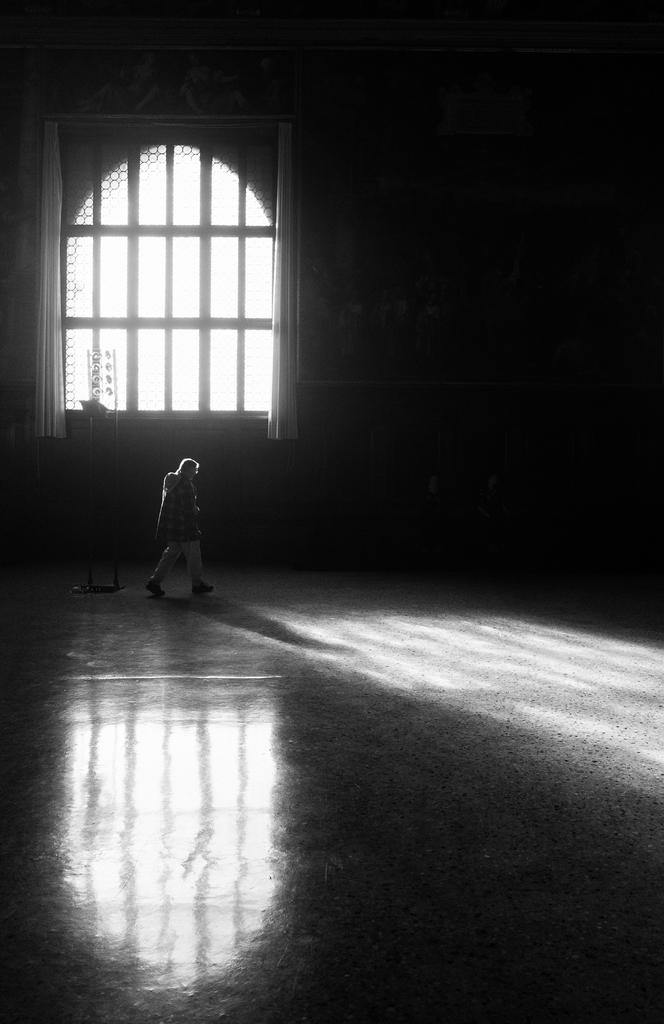What is the person in the image doing? There is a person walking in the image. What is at the bottom of the image? There is a floor at the bottom of the image. What can be seen in the background of the image? There is a window and a wall in the background of the image. What is associated with the window in the image? There is a curtain associated with the window. How many sisters are visible in the image? There are no sisters present in the image; it only features a person walking. What type of animal can be seen interacting with the curtain in the image? There is no animal present in the image; it only features a person walking, a floor, a window, a wall, and a curtain. 